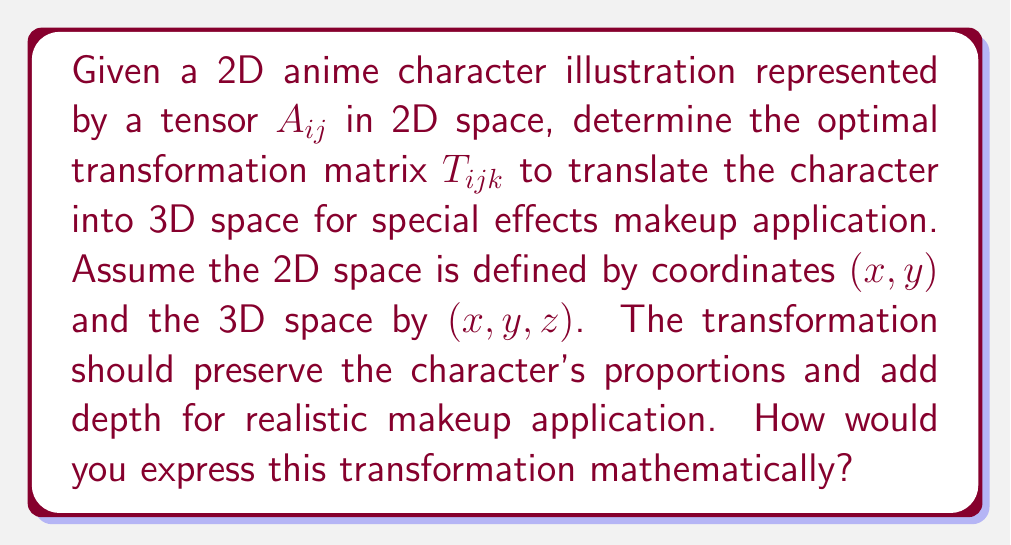What is the answer to this math problem? To solve this problem, we'll follow these steps:

1) First, we need to define our 2D tensor $A_{ij}$ representing the anime character:
   $$A_{ij} = \begin{pmatrix} a_{11} & a_{12} \\ a_{21} & a_{22} \end{pmatrix}$$

2) The transformation matrix $T_{ijk}$ will be a 3rd-order tensor to map 2D to 3D:
   $$T_{ijk} = \begin{pmatrix} 
   t_{111} & t_{112} & t_{113} \\
   t_{121} & t_{122} & t_{123} \\
   t_{211} & t_{212} & t_{213} \\
   t_{221} & t_{222} & t_{223}
   \end{pmatrix}$$

3) The transformation can be expressed as:
   $$B_{ijk} = A_{ij} \otimes T_{ijk}$$
   where $\otimes$ represents the tensor product.

4) To preserve proportions, we can set:
   $$t_{111} = t_{122} = 1$$
   $$t_{112} = t_{121} = 0$$

5) To add depth, we introduce a depth factor $d$ in the z-dimension:
   $$t_{113} = t_{123} = d$$

6) The remaining elements can be set to 0 for a simple translation.

7) Our optimal transformation matrix becomes:
   $$T_{ijk} = \begin{pmatrix} 
   1 & 0 & d \\
   0 & 1 & d \\
   0 & 0 & 0 \\
   0 & 0 & 0
   \end{pmatrix}$$

8) The resulting 3D representation $B_{ijk}$ will be:
   $$B_{ijk} = \begin{pmatrix} 
   a_{11} & a_{12} & d(a_{11} + a_{12}) \\
   a_{21} & a_{22} & d(a_{21} + a_{22})
   \end{pmatrix}$$

This transformation preserves the original 2D structure in the x-y plane while adding depth in the z-dimension, suitable for 3D special effects makeup application.
Answer: $$T_{ijk} = \begin{pmatrix} 
1 & 0 & d \\
0 & 1 & d \\
0 & 0 & 0 \\
0 & 0 & 0
\end{pmatrix}$$ 